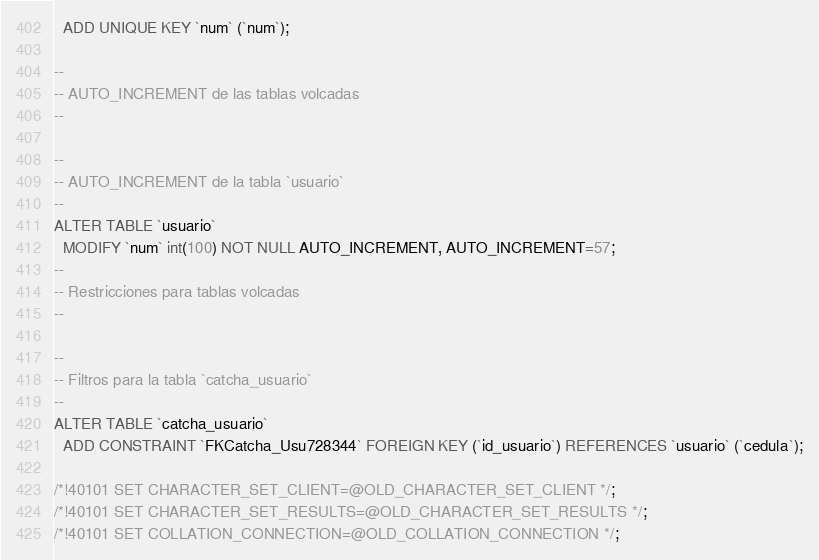Convert code to text. <code><loc_0><loc_0><loc_500><loc_500><_SQL_>  ADD UNIQUE KEY `num` (`num`);

--
-- AUTO_INCREMENT de las tablas volcadas
--

--
-- AUTO_INCREMENT de la tabla `usuario`
--
ALTER TABLE `usuario`
  MODIFY `num` int(100) NOT NULL AUTO_INCREMENT, AUTO_INCREMENT=57;
--
-- Restricciones para tablas volcadas
--

--
-- Filtros para la tabla `catcha_usuario`
--
ALTER TABLE `catcha_usuario`
  ADD CONSTRAINT `FKCatcha_Usu728344` FOREIGN KEY (`id_usuario`) REFERENCES `usuario` (`cedula`);

/*!40101 SET CHARACTER_SET_CLIENT=@OLD_CHARACTER_SET_CLIENT */;
/*!40101 SET CHARACTER_SET_RESULTS=@OLD_CHARACTER_SET_RESULTS */;
/*!40101 SET COLLATION_CONNECTION=@OLD_COLLATION_CONNECTION */;
</code> 